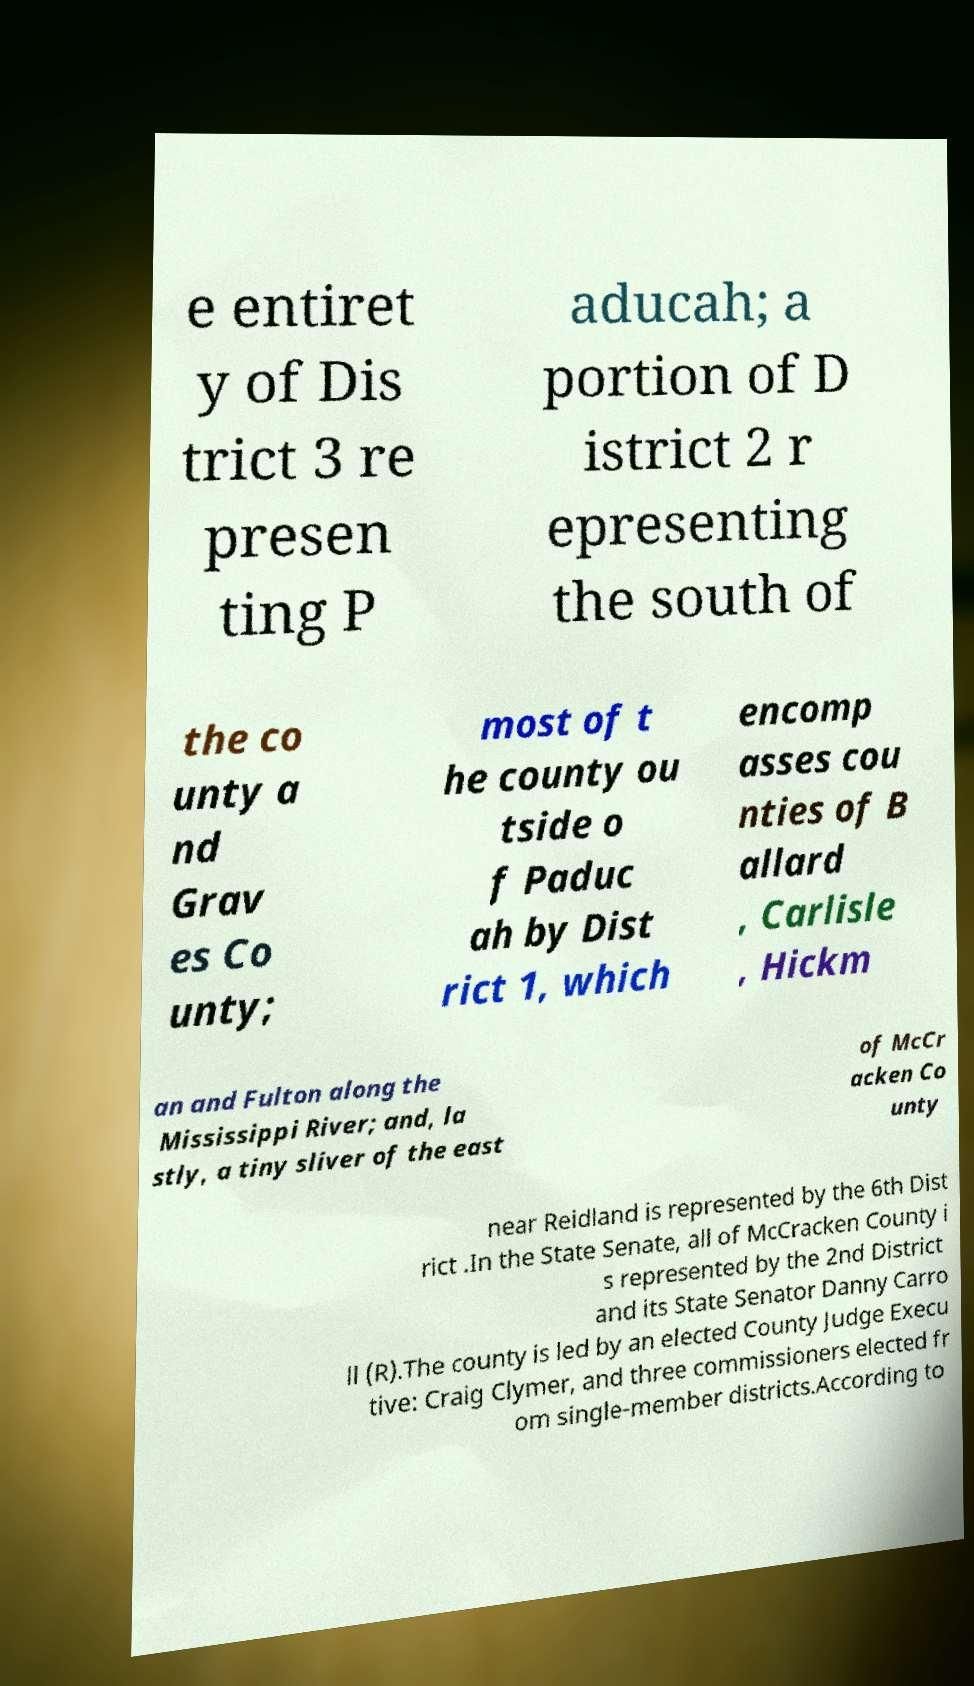Please read and relay the text visible in this image. What does it say? e entiret y of Dis trict 3 re presen ting P aducah; a portion of D istrict 2 r epresenting the south of the co unty a nd Grav es Co unty; most of t he county ou tside o f Paduc ah by Dist rict 1, which encomp asses cou nties of B allard , Carlisle , Hickm an and Fulton along the Mississippi River; and, la stly, a tiny sliver of the east of McCr acken Co unty near Reidland is represented by the 6th Dist rict .In the State Senate, all of McCracken County i s represented by the 2nd District and its State Senator Danny Carro ll (R).The county is led by an elected County Judge Execu tive: Craig Clymer, and three commissioners elected fr om single-member districts.According to 